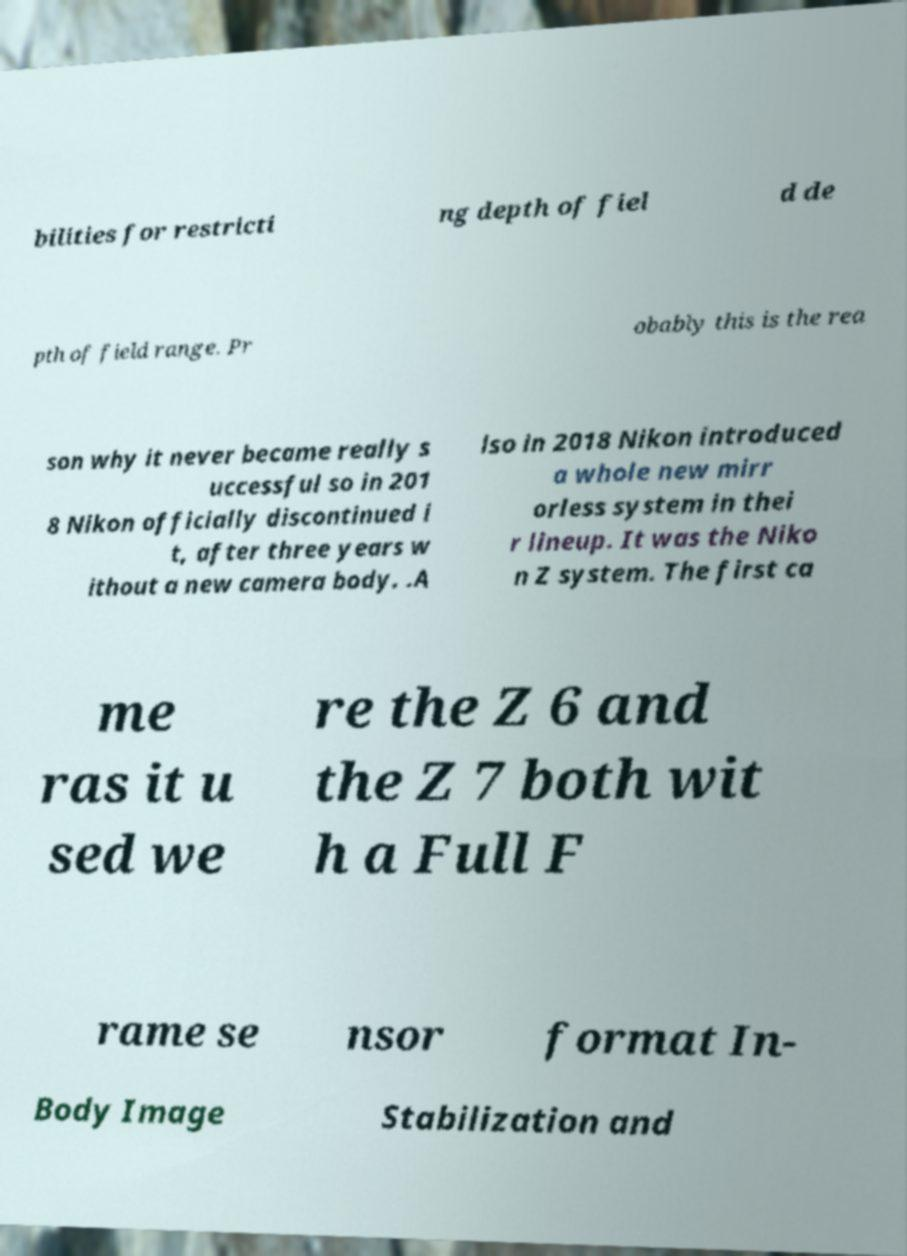For documentation purposes, I need the text within this image transcribed. Could you provide that? bilities for restricti ng depth of fiel d de pth of field range. Pr obably this is the rea son why it never became really s uccessful so in 201 8 Nikon officially discontinued i t, after three years w ithout a new camera body. .A lso in 2018 Nikon introduced a whole new mirr orless system in thei r lineup. It was the Niko n Z system. The first ca me ras it u sed we re the Z 6 and the Z 7 both wit h a Full F rame se nsor format In- Body Image Stabilization and 